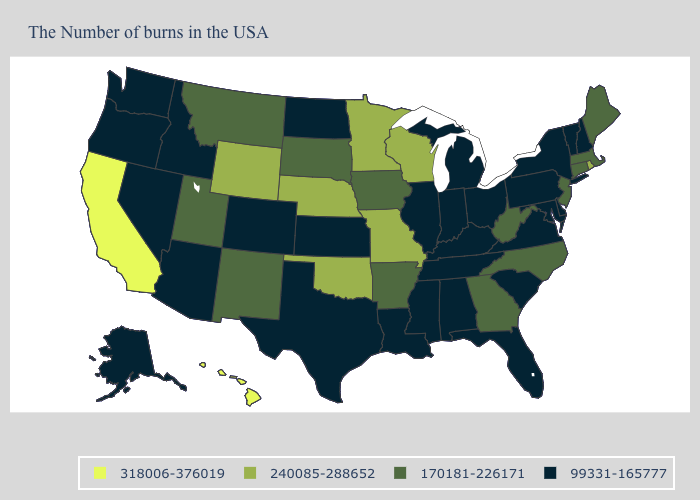What is the highest value in the USA?
Be succinct. 318006-376019. Name the states that have a value in the range 240085-288652?
Answer briefly. Rhode Island, Wisconsin, Missouri, Minnesota, Nebraska, Oklahoma, Wyoming. What is the value of New Jersey?
Answer briefly. 170181-226171. Among the states that border Colorado , does Wyoming have the highest value?
Keep it brief. Yes. What is the lowest value in states that border California?
Write a very short answer. 99331-165777. Does the first symbol in the legend represent the smallest category?
Short answer required. No. Does the first symbol in the legend represent the smallest category?
Give a very brief answer. No. What is the highest value in the Northeast ?
Give a very brief answer. 240085-288652. What is the value of Virginia?
Keep it brief. 99331-165777. Does the map have missing data?
Write a very short answer. No. Name the states that have a value in the range 99331-165777?
Short answer required. New Hampshire, Vermont, New York, Delaware, Maryland, Pennsylvania, Virginia, South Carolina, Ohio, Florida, Michigan, Kentucky, Indiana, Alabama, Tennessee, Illinois, Mississippi, Louisiana, Kansas, Texas, North Dakota, Colorado, Arizona, Idaho, Nevada, Washington, Oregon, Alaska. Among the states that border Ohio , does Michigan have the lowest value?
Keep it brief. Yes. Does the map have missing data?
Keep it brief. No. What is the value of Louisiana?
Keep it brief. 99331-165777. Is the legend a continuous bar?
Short answer required. No. 